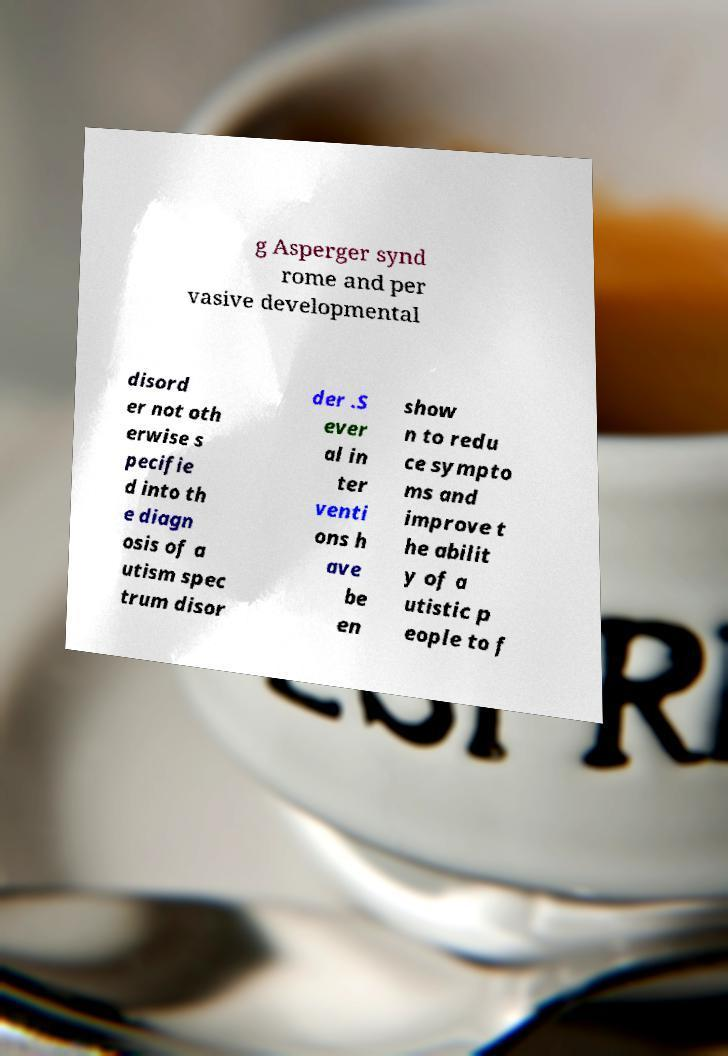I need the written content from this picture converted into text. Can you do that? g Asperger synd rome and per vasive developmental disord er not oth erwise s pecifie d into th e diagn osis of a utism spec trum disor der .S ever al in ter venti ons h ave be en show n to redu ce sympto ms and improve t he abilit y of a utistic p eople to f 